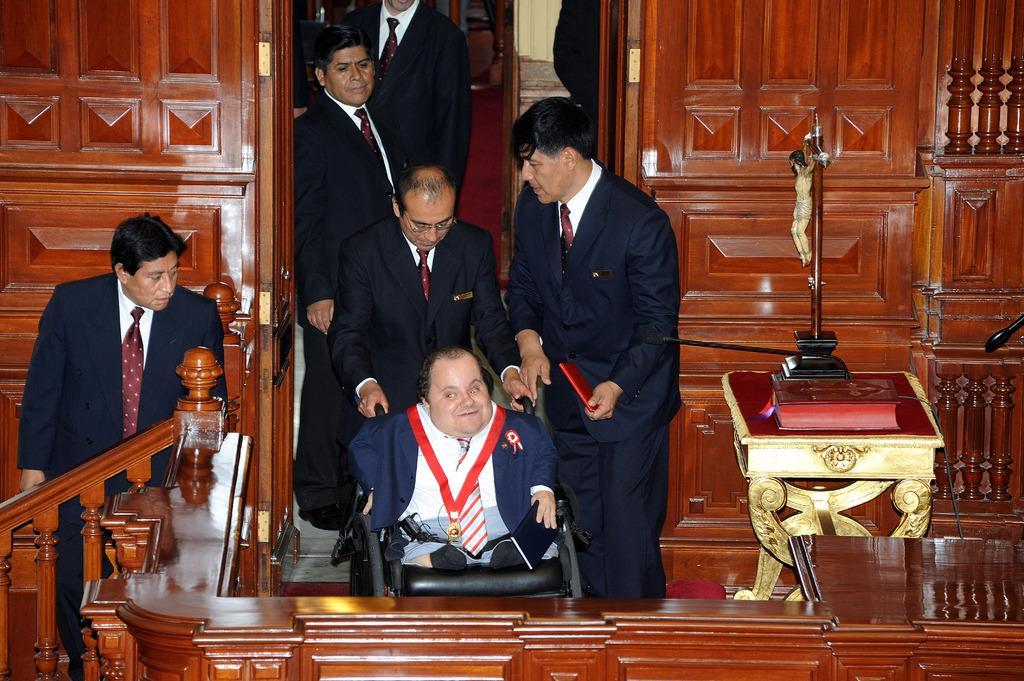Describe this image in one or two sentences. In this image I can see some people. On the right side, I can see some objects on the table. In the background, I can see the wooden wall. 